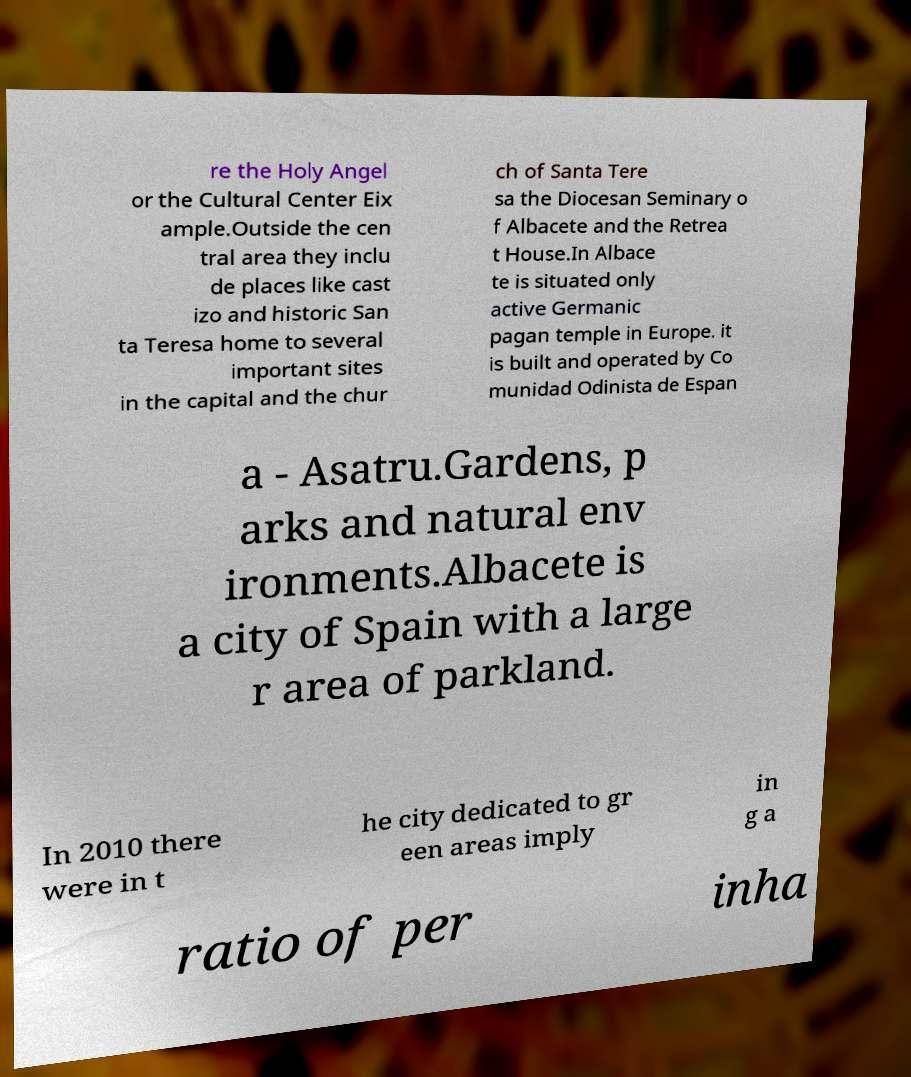What messages or text are displayed in this image? I need them in a readable, typed format. re the Holy Angel or the Cultural Center Eix ample.Outside the cen tral area they inclu de places like cast izo and historic San ta Teresa home to several important sites in the capital and the chur ch of Santa Tere sa the Diocesan Seminary o f Albacete and the Retrea t House.In Albace te is situated only active Germanic pagan temple in Europe. it is built and operated by Co munidad Odinista de Espan a - Asatru.Gardens, p arks and natural env ironments.Albacete is a city of Spain with a large r area of parkland. In 2010 there were in t he city dedicated to gr een areas imply in g a ratio of per inha 